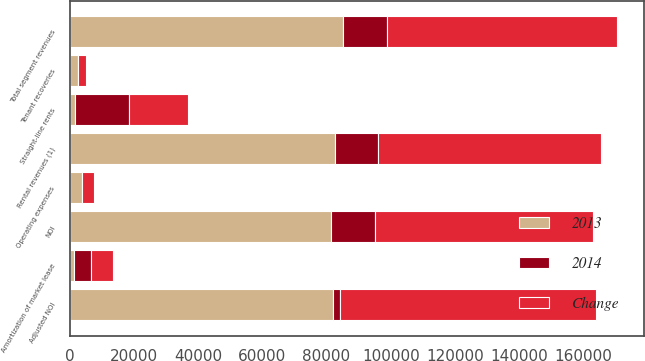<chart> <loc_0><loc_0><loc_500><loc_500><stacked_bar_chart><ecel><fcel>Rental revenues (1)<fcel>Tenant recoveries<fcel>Total segment revenues<fcel>Operating expenses<fcel>NOI<fcel>Straight-line rents<fcel>Amortization of market lease<fcel>Adjusted NOI<nl><fcel>2013<fcel>82667<fcel>2515<fcel>85182<fcel>3773<fcel>81409<fcel>1835<fcel>1369<fcel>81875<nl><fcel>Change<fcel>69213<fcel>2457<fcel>71670<fcel>3813<fcel>67857<fcel>18386<fcel>6825<fcel>79418<nl><fcel>2014<fcel>13454<fcel>58<fcel>13512<fcel>40<fcel>13552<fcel>16551<fcel>5456<fcel>2457<nl></chart> 